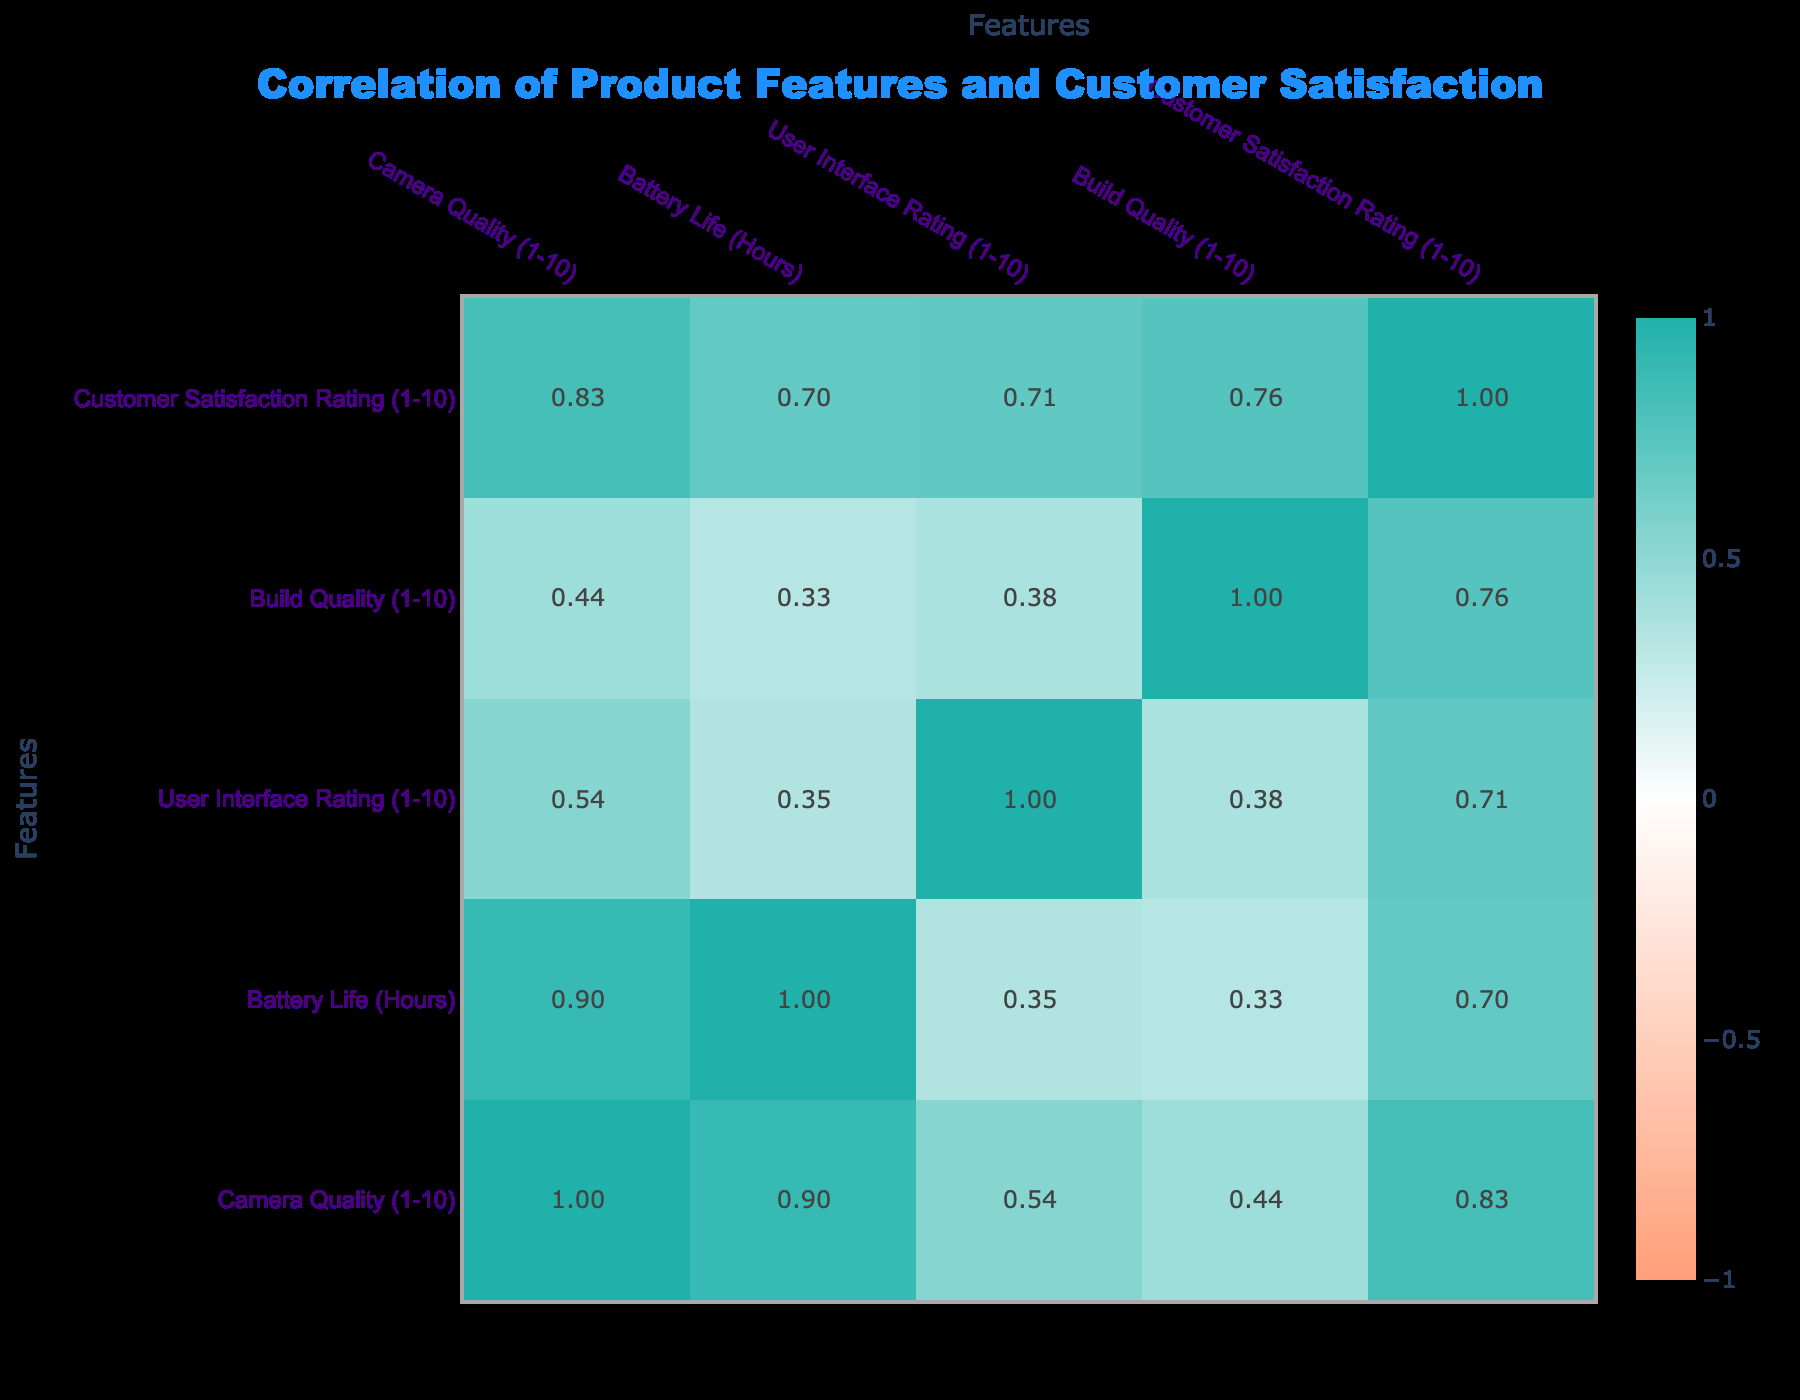What is the correlation coefficient between camera quality and customer satisfaction rating? The table shows that the correlation coefficient for camera quality and customer satisfaction rating is 0.78, indicating a strong positive correlation. This means that as camera quality increases, customer satisfaction ratings tend to increase as well.
Answer: 0.78 What is the user interface rating for the Google Pixel 6? By searching through the table, the user interface rating for the Google Pixel 6 is found to be 10.
Answer: 10 Is there a positive correlation between build quality and customer satisfaction? Yes, the table indicates a correlation coefficient of 0.67 between build quality and customer satisfaction, which shows a moderate positive correlation.
Answer: Yes What is the average battery life of all the products listed? The sum of the battery lives is 20 + 18 + 24 + 15 + 16 + 20 + 17 + 12 + 22 + 15 =  189 hours. There are 10 products, so the average battery life is 189 / 10 = 18.9 hours.
Answer: 18.9 Which product has the highest customer satisfaction rating, and what is that rating? Upon reviewing the table, the product with the highest customer satisfaction rating is the Apple iPhone 14, with a rating of 9.
Answer: Apple iPhone 14, 9 What features have a correlation coefficient above 0.7 with customer satisfaction ratings? According to the table, the features that have a correlation coefficient above 0.7 with customer satisfaction ratings are camera quality (0.78) and build quality (0.67, close but below 0.7).
Answer: Camera quality (0.78) Does the Xiaomi Mi 11 have a higher satisfaction rating than the OnePlus 10 Pro? No, the Xiaomi Mi 11 has a customer satisfaction rating of 7, while the OnePlus 10 Pro has a rating of 7 as well. Thus, they are equal, confirming that Xiaomi Mi 11 does not have a higher rating.
Answer: No What is the difference in battery life between the Huawei P40 and the Nokia G50? The Huawei P40 has a battery life of 22 hours, while the Nokia G50 has a battery life of 15 hours. The difference is 22 - 15 = 7 hours.
Answer: 7 Which feature correlates the least with customer satisfaction ratings? The feature that correlates the least with customer satisfaction ratings is the user interface rating, which has a correlation coefficient of 0.53.
Answer: User interface rating, 0.53 